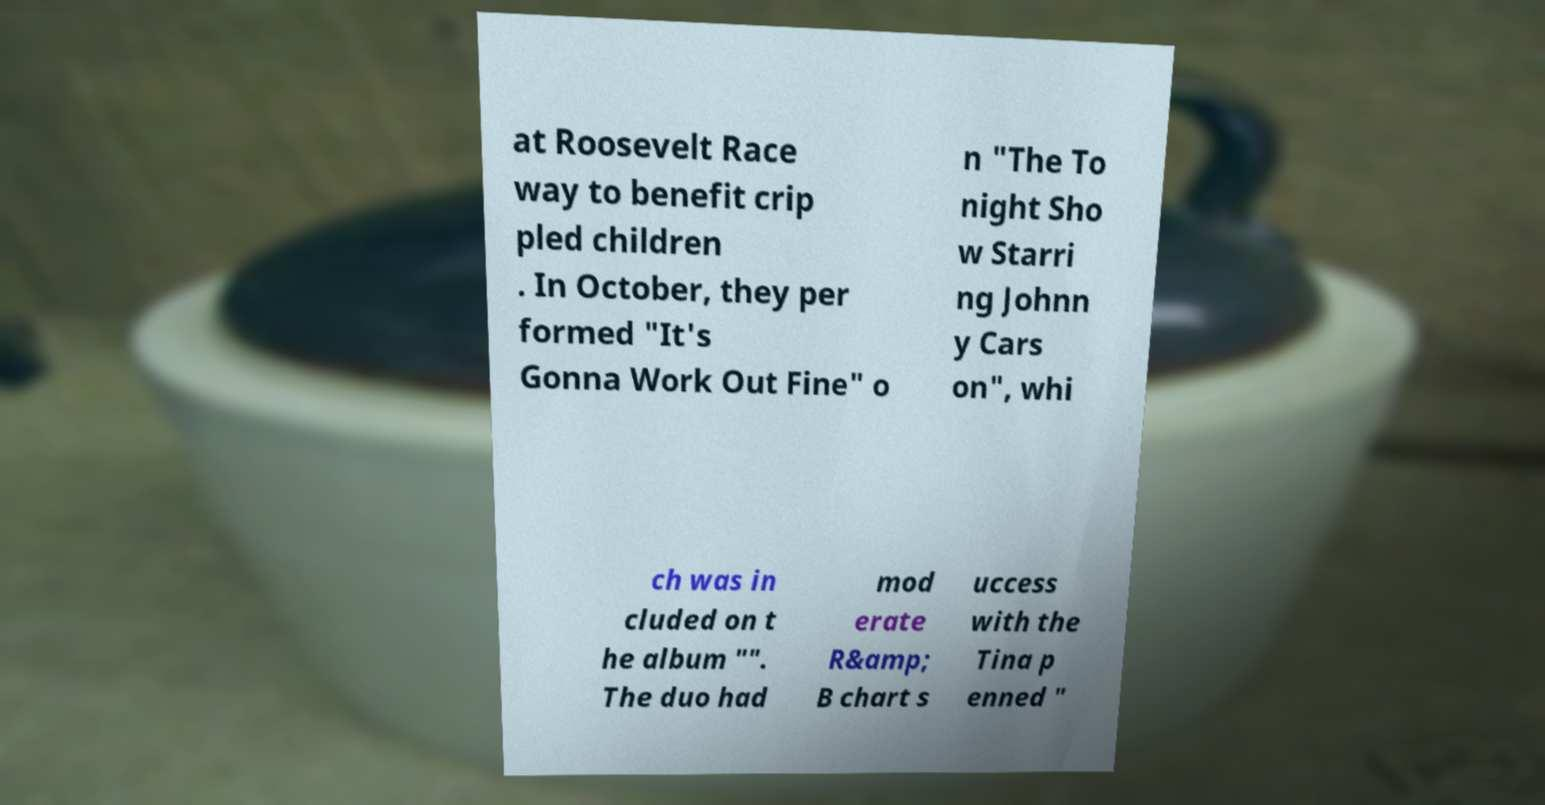Can you accurately transcribe the text from the provided image for me? at Roosevelt Race way to benefit crip pled children . In October, they per formed "It's Gonna Work Out Fine" o n "The To night Sho w Starri ng Johnn y Cars on", whi ch was in cluded on t he album "". The duo had mod erate R&amp; B chart s uccess with the Tina p enned " 